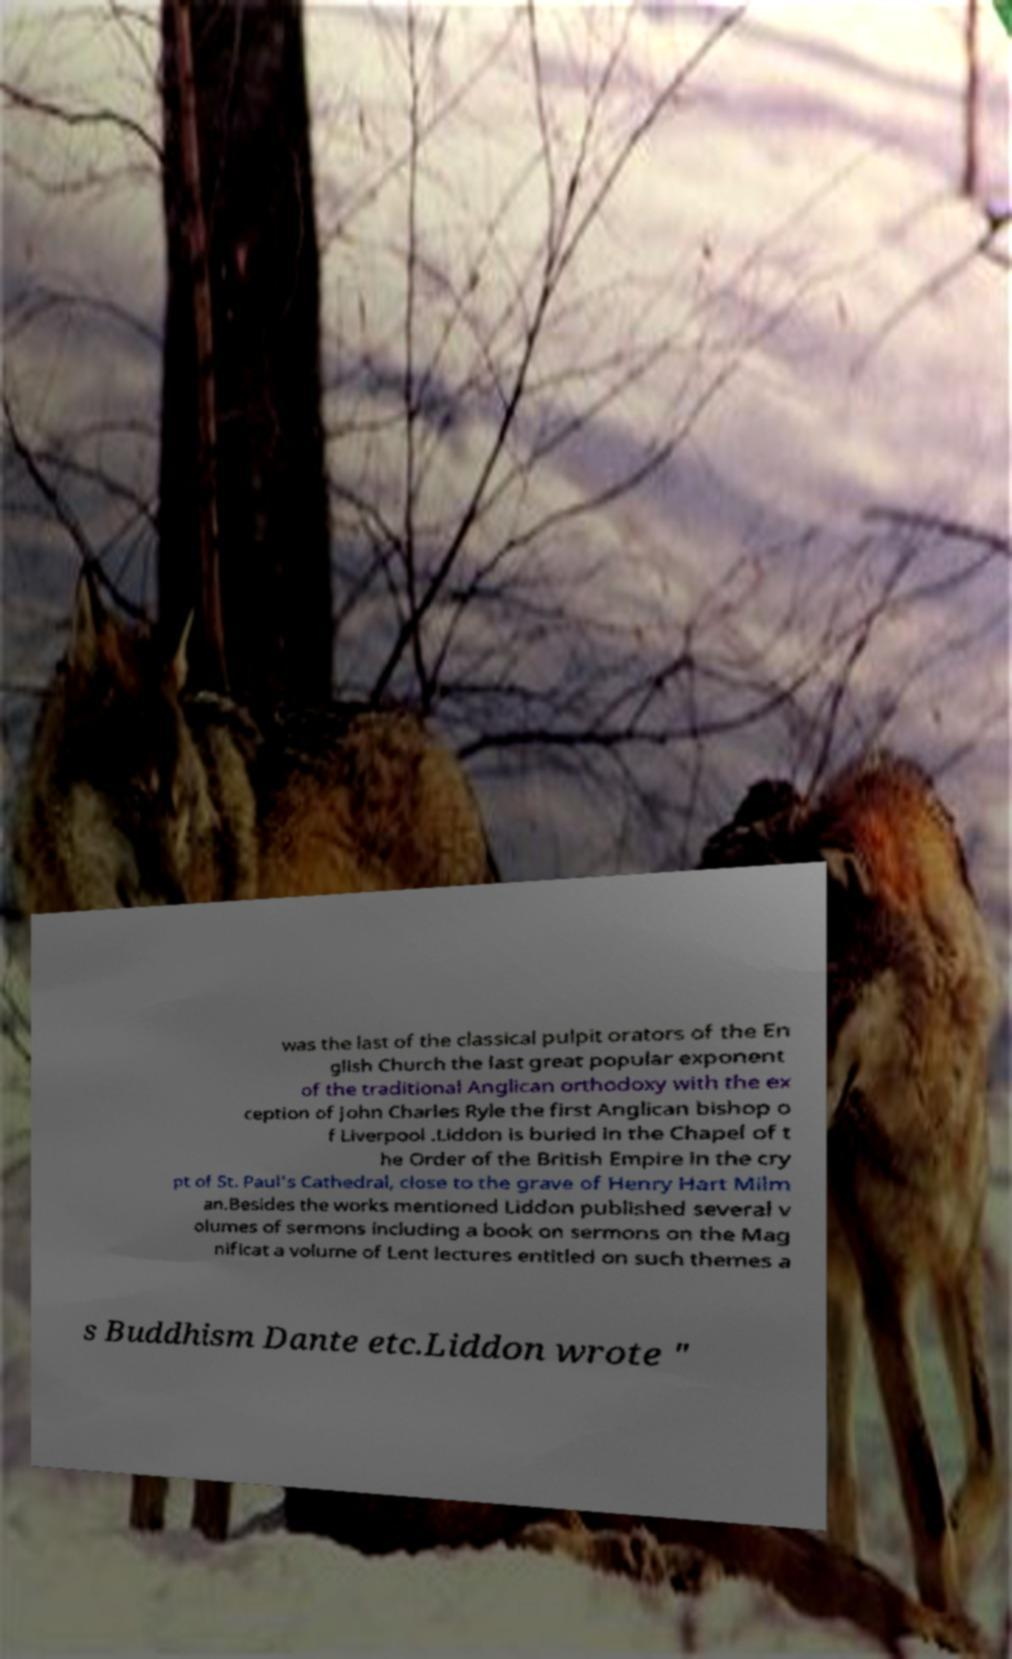Please read and relay the text visible in this image. What does it say? was the last of the classical pulpit orators of the En glish Church the last great popular exponent of the traditional Anglican orthodoxy with the ex ception of John Charles Ryle the first Anglican bishop o f Liverpool .Liddon is buried in the Chapel of t he Order of the British Empire in the cry pt of St. Paul's Cathedral, close to the grave of Henry Hart Milm an.Besides the works mentioned Liddon published several v olumes of sermons including a book on sermons on the Mag nificat a volume of Lent lectures entitled on such themes a s Buddhism Dante etc.Liddon wrote " 